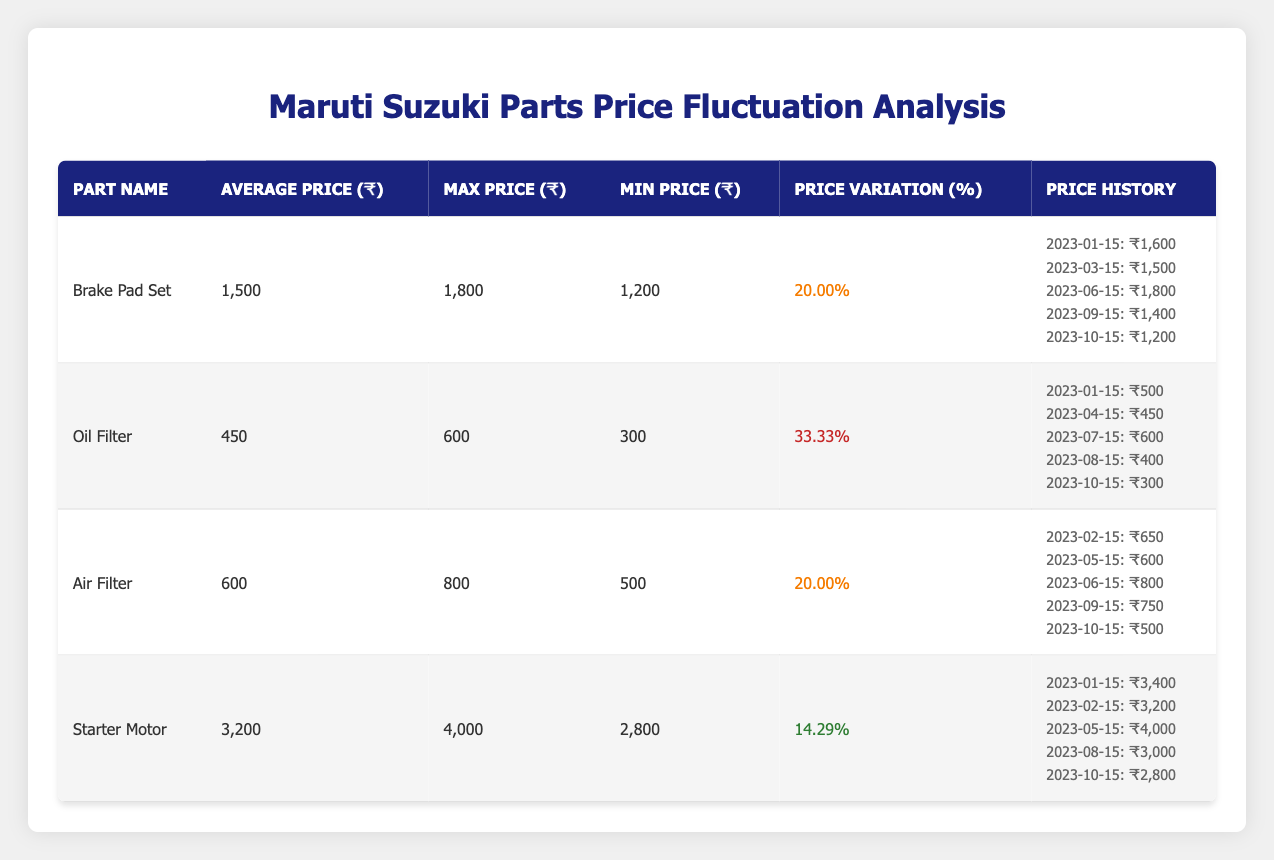What is the average price of the Oil Filter? The table shows that the average price of the Oil Filter is listed directly in the "Average Price (₹)" column next to the part name. For the Oil Filter, this amount is 450.
Answer: 450 What was the maximum price of the Air Filter? The maximum price of the Air Filter can be found in the "Max Price (₹)" column in the table. It indicates that the maximum price is 800.
Answer: 800 Is the price variation percentage of the Brake Pad Set greater than that of the Starter Motor? The percentage for the Brake Pad Set is 20.00%, while for the Starter Motor, it is 14.29%. Since 20.00% is greater than 14.29%, the answer is yes.
Answer: Yes What is the price increase when comparing the maximum price of the Brake Pad Set to its average price? The maximum price of the Brake Pad Set is 1800, and its average price is 1500. The difference is calculated as 1800 - 1500 = 300.
Answer: 300 On which date did the Oil Filter have its highest price? By reviewing the dates listed for the Oil Filter, the date with the highest recorded price of 600 is found on 2023-07-15.
Answer: 2023-07-15 What is the difference between the minimum and maximum price of the Starter Motor? The maximum price is 4000 and the minimum price is 2800. To find the difference, we subtract: 4000 - 2800 = 1200.
Answer: 1200 Are there any parts with a price variation percentage of less than 20%? The table lists the price variation percentages. Only the Starter Motor has a variation of 14.29%, which is indeed less than 20%. Therefore, the answer is yes.
Answer: Yes What is the average price of the parts listed in the table? The average price is calculated by summing the average prices of all parts: 1500 (Brake Pad Set) + 450 (Oil Filter) + 600 (Air Filter) + 3200 (Starter Motor) = 4750, and then dividing by the number of parts (4): 4750 / 4 = 1187.5.
Answer: 1187.5 Which part had the lowest price on October 15, 2023? The price history on October 15 shows that the Brake Pad Set is priced at 1200, the Oil Filter at 300, the Air Filter at 500, and the Starter Motor at 2800. Therefore, the Oil Filter has the lowest price at 300.
Answer: Oil Filter 